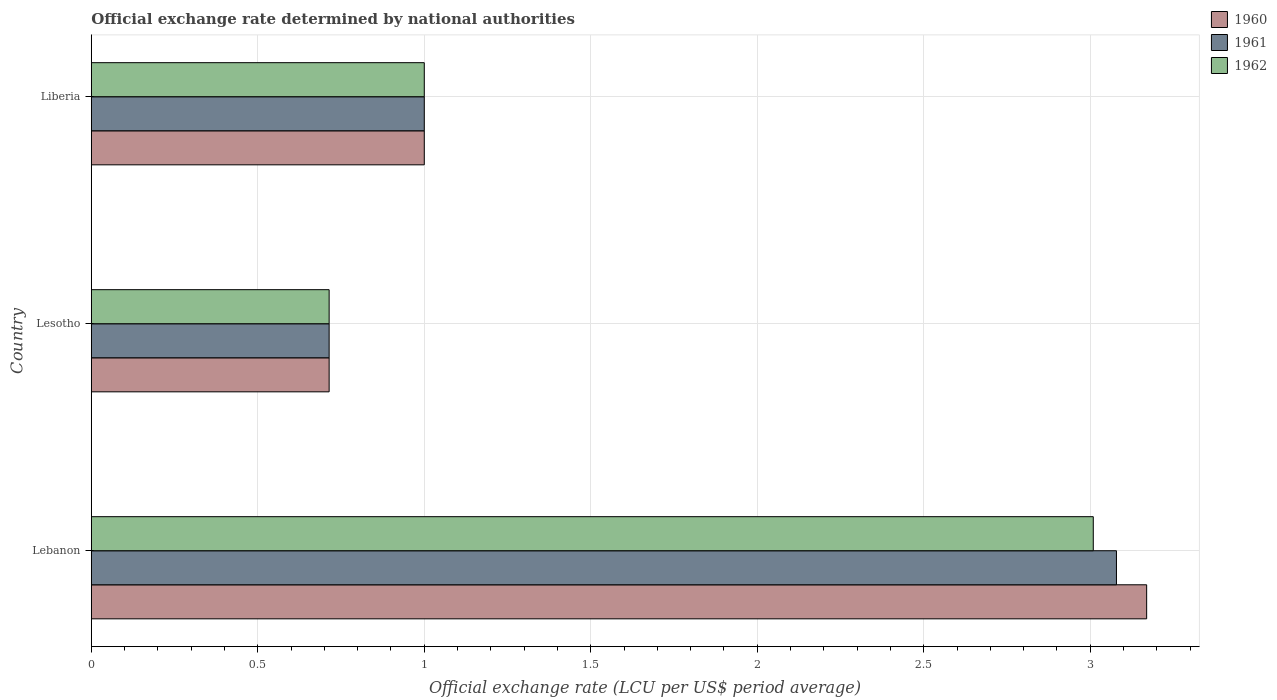How many groups of bars are there?
Ensure brevity in your answer.  3. Are the number of bars per tick equal to the number of legend labels?
Give a very brief answer. Yes. What is the label of the 1st group of bars from the top?
Your response must be concise. Liberia. In how many cases, is the number of bars for a given country not equal to the number of legend labels?
Your answer should be compact. 0. What is the official exchange rate in 1961 in Lesotho?
Your answer should be very brief. 0.71. Across all countries, what is the maximum official exchange rate in 1961?
Give a very brief answer. 3.08. Across all countries, what is the minimum official exchange rate in 1961?
Your answer should be compact. 0.71. In which country was the official exchange rate in 1960 maximum?
Offer a very short reply. Lebanon. In which country was the official exchange rate in 1962 minimum?
Give a very brief answer. Lesotho. What is the total official exchange rate in 1960 in the graph?
Your response must be concise. 4.88. What is the difference between the official exchange rate in 1962 in Lesotho and that in Liberia?
Offer a very short reply. -0.29. What is the difference between the official exchange rate in 1961 in Lesotho and the official exchange rate in 1960 in Liberia?
Provide a succinct answer. -0.29. What is the average official exchange rate in 1962 per country?
Keep it short and to the point. 1.57. In how many countries, is the official exchange rate in 1960 greater than 0.9 LCU?
Your answer should be compact. 2. What is the ratio of the official exchange rate in 1960 in Lebanon to that in Lesotho?
Keep it short and to the point. 4.44. What is the difference between the highest and the second highest official exchange rate in 1961?
Provide a succinct answer. 2.08. What is the difference between the highest and the lowest official exchange rate in 1962?
Your answer should be very brief. 2.29. In how many countries, is the official exchange rate in 1962 greater than the average official exchange rate in 1962 taken over all countries?
Your answer should be very brief. 1. Is the sum of the official exchange rate in 1960 in Lebanon and Lesotho greater than the maximum official exchange rate in 1961 across all countries?
Give a very brief answer. Yes. What does the 1st bar from the bottom in Liberia represents?
Offer a very short reply. 1960. Is it the case that in every country, the sum of the official exchange rate in 1962 and official exchange rate in 1961 is greater than the official exchange rate in 1960?
Ensure brevity in your answer.  Yes. How many bars are there?
Make the answer very short. 9. Are all the bars in the graph horizontal?
Provide a short and direct response. Yes. What is the difference between two consecutive major ticks on the X-axis?
Make the answer very short. 0.5. Does the graph contain grids?
Your answer should be compact. Yes. Where does the legend appear in the graph?
Ensure brevity in your answer.  Top right. How many legend labels are there?
Your answer should be very brief. 3. What is the title of the graph?
Your response must be concise. Official exchange rate determined by national authorities. Does "1985" appear as one of the legend labels in the graph?
Provide a succinct answer. No. What is the label or title of the X-axis?
Provide a short and direct response. Official exchange rate (LCU per US$ period average). What is the Official exchange rate (LCU per US$ period average) of 1960 in Lebanon?
Offer a terse response. 3.17. What is the Official exchange rate (LCU per US$ period average) of 1961 in Lebanon?
Provide a succinct answer. 3.08. What is the Official exchange rate (LCU per US$ period average) in 1962 in Lebanon?
Your answer should be very brief. 3.01. What is the Official exchange rate (LCU per US$ period average) of 1960 in Lesotho?
Your answer should be compact. 0.71. What is the Official exchange rate (LCU per US$ period average) in 1961 in Lesotho?
Offer a very short reply. 0.71. What is the Official exchange rate (LCU per US$ period average) in 1962 in Lesotho?
Provide a short and direct response. 0.71. Across all countries, what is the maximum Official exchange rate (LCU per US$ period average) of 1960?
Your answer should be compact. 3.17. Across all countries, what is the maximum Official exchange rate (LCU per US$ period average) of 1961?
Provide a short and direct response. 3.08. Across all countries, what is the maximum Official exchange rate (LCU per US$ period average) in 1962?
Your answer should be very brief. 3.01. Across all countries, what is the minimum Official exchange rate (LCU per US$ period average) of 1960?
Give a very brief answer. 0.71. Across all countries, what is the minimum Official exchange rate (LCU per US$ period average) of 1961?
Your answer should be very brief. 0.71. Across all countries, what is the minimum Official exchange rate (LCU per US$ period average) of 1962?
Your answer should be very brief. 0.71. What is the total Official exchange rate (LCU per US$ period average) of 1960 in the graph?
Give a very brief answer. 4.88. What is the total Official exchange rate (LCU per US$ period average) in 1961 in the graph?
Your response must be concise. 4.79. What is the total Official exchange rate (LCU per US$ period average) of 1962 in the graph?
Provide a succinct answer. 4.72. What is the difference between the Official exchange rate (LCU per US$ period average) in 1960 in Lebanon and that in Lesotho?
Offer a very short reply. 2.46. What is the difference between the Official exchange rate (LCU per US$ period average) of 1961 in Lebanon and that in Lesotho?
Your response must be concise. 2.36. What is the difference between the Official exchange rate (LCU per US$ period average) in 1962 in Lebanon and that in Lesotho?
Offer a very short reply. 2.29. What is the difference between the Official exchange rate (LCU per US$ period average) in 1960 in Lebanon and that in Liberia?
Your answer should be very brief. 2.17. What is the difference between the Official exchange rate (LCU per US$ period average) of 1961 in Lebanon and that in Liberia?
Give a very brief answer. 2.08. What is the difference between the Official exchange rate (LCU per US$ period average) of 1962 in Lebanon and that in Liberia?
Ensure brevity in your answer.  2.01. What is the difference between the Official exchange rate (LCU per US$ period average) of 1960 in Lesotho and that in Liberia?
Ensure brevity in your answer.  -0.29. What is the difference between the Official exchange rate (LCU per US$ period average) of 1961 in Lesotho and that in Liberia?
Provide a short and direct response. -0.29. What is the difference between the Official exchange rate (LCU per US$ period average) of 1962 in Lesotho and that in Liberia?
Offer a very short reply. -0.29. What is the difference between the Official exchange rate (LCU per US$ period average) of 1960 in Lebanon and the Official exchange rate (LCU per US$ period average) of 1961 in Lesotho?
Give a very brief answer. 2.46. What is the difference between the Official exchange rate (LCU per US$ period average) in 1960 in Lebanon and the Official exchange rate (LCU per US$ period average) in 1962 in Lesotho?
Make the answer very short. 2.46. What is the difference between the Official exchange rate (LCU per US$ period average) in 1961 in Lebanon and the Official exchange rate (LCU per US$ period average) in 1962 in Lesotho?
Offer a terse response. 2.36. What is the difference between the Official exchange rate (LCU per US$ period average) in 1960 in Lebanon and the Official exchange rate (LCU per US$ period average) in 1961 in Liberia?
Offer a very short reply. 2.17. What is the difference between the Official exchange rate (LCU per US$ period average) of 1960 in Lebanon and the Official exchange rate (LCU per US$ period average) of 1962 in Liberia?
Your answer should be very brief. 2.17. What is the difference between the Official exchange rate (LCU per US$ period average) of 1961 in Lebanon and the Official exchange rate (LCU per US$ period average) of 1962 in Liberia?
Offer a terse response. 2.08. What is the difference between the Official exchange rate (LCU per US$ period average) in 1960 in Lesotho and the Official exchange rate (LCU per US$ period average) in 1961 in Liberia?
Provide a succinct answer. -0.29. What is the difference between the Official exchange rate (LCU per US$ period average) of 1960 in Lesotho and the Official exchange rate (LCU per US$ period average) of 1962 in Liberia?
Your answer should be compact. -0.29. What is the difference between the Official exchange rate (LCU per US$ period average) of 1961 in Lesotho and the Official exchange rate (LCU per US$ period average) of 1962 in Liberia?
Offer a very short reply. -0.29. What is the average Official exchange rate (LCU per US$ period average) in 1960 per country?
Make the answer very short. 1.63. What is the average Official exchange rate (LCU per US$ period average) of 1961 per country?
Offer a terse response. 1.6. What is the average Official exchange rate (LCU per US$ period average) of 1962 per country?
Give a very brief answer. 1.57. What is the difference between the Official exchange rate (LCU per US$ period average) in 1960 and Official exchange rate (LCU per US$ period average) in 1961 in Lebanon?
Offer a very short reply. 0.09. What is the difference between the Official exchange rate (LCU per US$ period average) in 1960 and Official exchange rate (LCU per US$ period average) in 1962 in Lebanon?
Provide a succinct answer. 0.16. What is the difference between the Official exchange rate (LCU per US$ period average) of 1961 and Official exchange rate (LCU per US$ period average) of 1962 in Lebanon?
Your answer should be very brief. 0.07. What is the difference between the Official exchange rate (LCU per US$ period average) in 1961 and Official exchange rate (LCU per US$ period average) in 1962 in Lesotho?
Provide a succinct answer. 0. What is the difference between the Official exchange rate (LCU per US$ period average) of 1960 and Official exchange rate (LCU per US$ period average) of 1962 in Liberia?
Give a very brief answer. 0. What is the ratio of the Official exchange rate (LCU per US$ period average) in 1960 in Lebanon to that in Lesotho?
Provide a succinct answer. 4.44. What is the ratio of the Official exchange rate (LCU per US$ period average) of 1961 in Lebanon to that in Lesotho?
Provide a short and direct response. 4.31. What is the ratio of the Official exchange rate (LCU per US$ period average) of 1962 in Lebanon to that in Lesotho?
Offer a terse response. 4.21. What is the ratio of the Official exchange rate (LCU per US$ period average) in 1960 in Lebanon to that in Liberia?
Make the answer very short. 3.17. What is the ratio of the Official exchange rate (LCU per US$ period average) in 1961 in Lebanon to that in Liberia?
Keep it short and to the point. 3.08. What is the ratio of the Official exchange rate (LCU per US$ period average) of 1962 in Lebanon to that in Liberia?
Offer a very short reply. 3.01. What is the ratio of the Official exchange rate (LCU per US$ period average) of 1961 in Lesotho to that in Liberia?
Offer a terse response. 0.71. What is the ratio of the Official exchange rate (LCU per US$ period average) of 1962 in Lesotho to that in Liberia?
Ensure brevity in your answer.  0.71. What is the difference between the highest and the second highest Official exchange rate (LCU per US$ period average) of 1960?
Offer a very short reply. 2.17. What is the difference between the highest and the second highest Official exchange rate (LCU per US$ period average) in 1961?
Offer a terse response. 2.08. What is the difference between the highest and the second highest Official exchange rate (LCU per US$ period average) in 1962?
Provide a succinct answer. 2.01. What is the difference between the highest and the lowest Official exchange rate (LCU per US$ period average) in 1960?
Offer a very short reply. 2.46. What is the difference between the highest and the lowest Official exchange rate (LCU per US$ period average) of 1961?
Offer a terse response. 2.36. What is the difference between the highest and the lowest Official exchange rate (LCU per US$ period average) in 1962?
Make the answer very short. 2.29. 